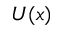<formula> <loc_0><loc_0><loc_500><loc_500>U ( x )</formula> 